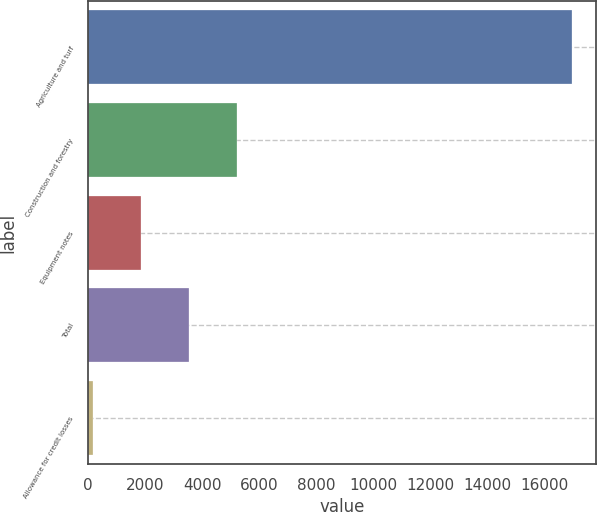<chart> <loc_0><loc_0><loc_500><loc_500><bar_chart><fcel>Agriculture and turf<fcel>Construction and forestry<fcel>Equipment notes<fcel>Total<fcel>Allowance for credit losses<nl><fcel>16970<fcel>5203.7<fcel>1841.9<fcel>3522.8<fcel>161<nl></chart> 